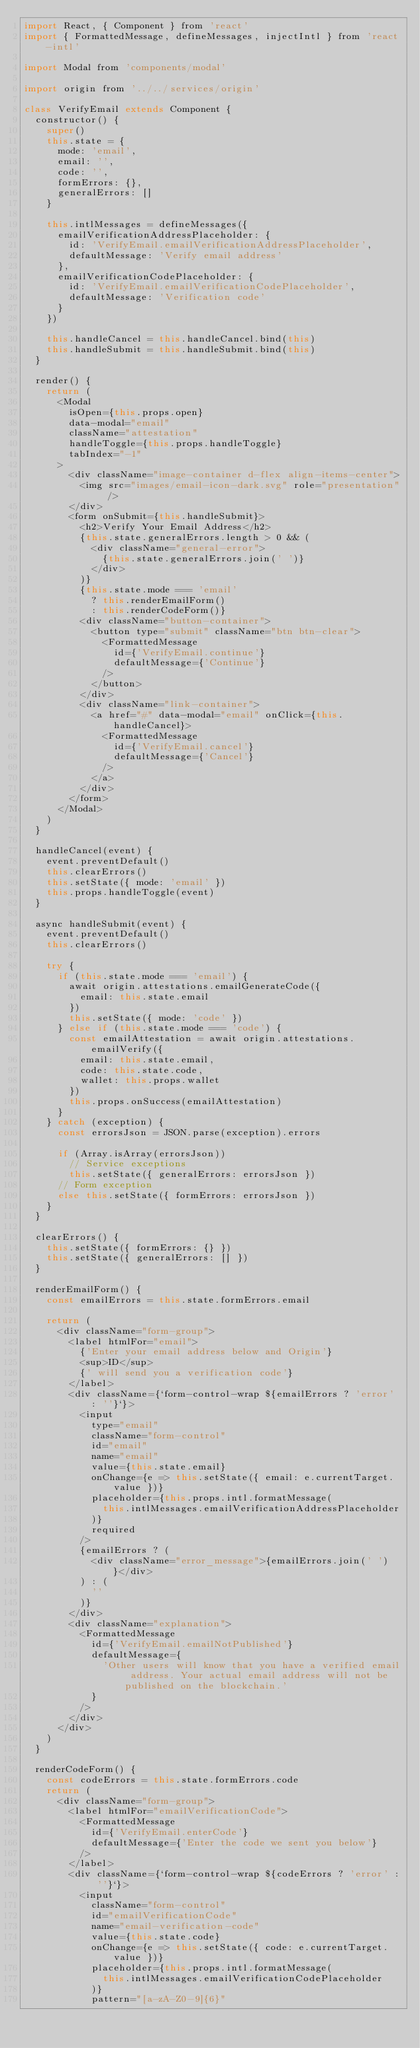Convert code to text. <code><loc_0><loc_0><loc_500><loc_500><_JavaScript_>import React, { Component } from 'react'
import { FormattedMessage, defineMessages, injectIntl } from 'react-intl'

import Modal from 'components/modal'

import origin from '../../services/origin'

class VerifyEmail extends Component {
  constructor() {
    super()
    this.state = {
      mode: 'email',
      email: '',
      code: '',
      formErrors: {},
      generalErrors: []
    }

    this.intlMessages = defineMessages({
      emailVerificationAddressPlaceholder: {
        id: 'VerifyEmail.emailVerificationAddressPlaceholder',
        defaultMessage: 'Verify email address'
      },
      emailVerificationCodePlaceholder: {
        id: 'VerifyEmail.emailVerificationCodePlaceholder',
        defaultMessage: 'Verification code'
      }
    })

    this.handleCancel = this.handleCancel.bind(this)
    this.handleSubmit = this.handleSubmit.bind(this)
  }

  render() {
    return (
      <Modal
        isOpen={this.props.open}
        data-modal="email"
        className="attestation"
        handleToggle={this.props.handleToggle}
        tabIndex="-1"
      >
        <div className="image-container d-flex align-items-center">
          <img src="images/email-icon-dark.svg" role="presentation" />
        </div>
        <form onSubmit={this.handleSubmit}>
          <h2>Verify Your Email Address</h2>
          {this.state.generalErrors.length > 0 && (
            <div className="general-error">
              {this.state.generalErrors.join(' ')}
            </div>
          )}
          {this.state.mode === 'email'
            ? this.renderEmailForm()
            : this.renderCodeForm()}
          <div className="button-container">
            <button type="submit" className="btn btn-clear">
              <FormattedMessage
                id={'VerifyEmail.continue'}
                defaultMessage={'Continue'}
              />
            </button>
          </div>
          <div className="link-container">
            <a href="#" data-modal="email" onClick={this.handleCancel}>
              <FormattedMessage
                id={'VerifyEmail.cancel'}
                defaultMessage={'Cancel'}
              />
            </a>
          </div>
        </form>
      </Modal>
    )
  }

  handleCancel(event) {
    event.preventDefault()
    this.clearErrors()
    this.setState({ mode: 'email' })
    this.props.handleToggle(event)
  }

  async handleSubmit(event) {
    event.preventDefault()
    this.clearErrors()

    try {
      if (this.state.mode === 'email') {
        await origin.attestations.emailGenerateCode({
          email: this.state.email
        })
        this.setState({ mode: 'code' })
      } else if (this.state.mode === 'code') {
        const emailAttestation = await origin.attestations.emailVerify({
          email: this.state.email,
          code: this.state.code,
          wallet: this.props.wallet
        })
        this.props.onSuccess(emailAttestation)
      }
    } catch (exception) {
      const errorsJson = JSON.parse(exception).errors

      if (Array.isArray(errorsJson))
        // Service exceptions
        this.setState({ generalErrors: errorsJson })
      // Form exception
      else this.setState({ formErrors: errorsJson })
    }
  }

  clearErrors() {
    this.setState({ formErrors: {} })
    this.setState({ generalErrors: [] })
  }

  renderEmailForm() {
    const emailErrors = this.state.formErrors.email

    return (
      <div className="form-group">
        <label htmlFor="email">
          {'Enter your email address below and Origin'}
          <sup>ID</sup>
          {' will send you a verification code'}
        </label>
        <div className={`form-control-wrap ${emailErrors ? 'error' : ''}`}>
          <input
            type="email"
            className="form-control"
            id="email"
            name="email"
            value={this.state.email}
            onChange={e => this.setState({ email: e.currentTarget.value })}
            placeholder={this.props.intl.formatMessage(
              this.intlMessages.emailVerificationAddressPlaceholder
            )}
            required
          />
          {emailErrors ? (
            <div className="error_message">{emailErrors.join(' ')}</div>
          ) : (
            ''
          )}
        </div>
        <div className="explanation">
          <FormattedMessage
            id={'VerifyEmail.emailNotPublished'}
            defaultMessage={
              'Other users will know that you have a verified email address. Your actual email address will not be published on the blockchain.'
            }
          />
        </div>
      </div>
    )
  }

  renderCodeForm() {
    const codeErrors = this.state.formErrors.code
    return (
      <div className="form-group">
        <label htmlFor="emailVerificationCode">
          <FormattedMessage
            id={'VerifyEmail.enterCode'}
            defaultMessage={'Enter the code we sent you below'}
          />
        </label>
        <div className={`form-control-wrap ${codeErrors ? 'error' : ''}`}>
          <input
            className="form-control"
            id="emailVerificationCode"
            name="email-verification-code"
            value={this.state.code}
            onChange={e => this.setState({ code: e.currentTarget.value })}
            placeholder={this.props.intl.formatMessage(
              this.intlMessages.emailVerificationCodePlaceholder
            )}
            pattern="[a-zA-Z0-9]{6}"</code> 